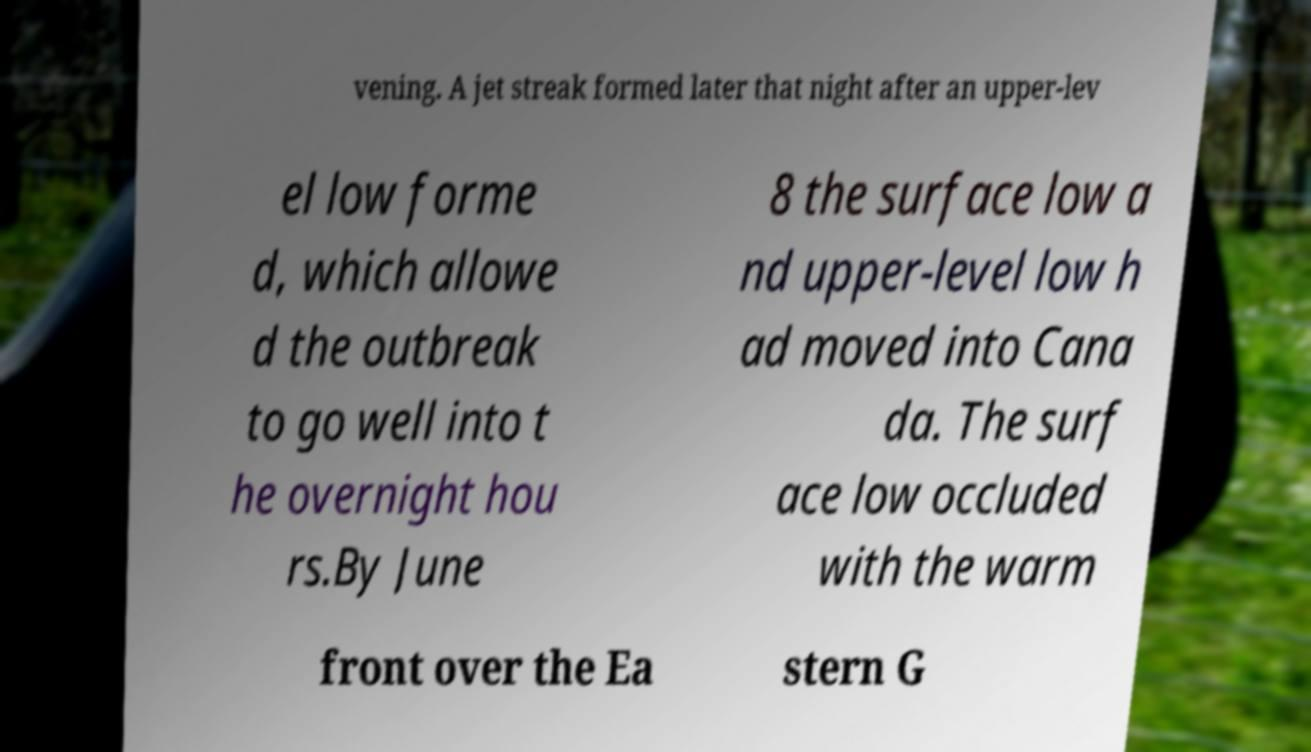Could you assist in decoding the text presented in this image and type it out clearly? vening. A jet streak formed later that night after an upper-lev el low forme d, which allowe d the outbreak to go well into t he overnight hou rs.By June 8 the surface low a nd upper-level low h ad moved into Cana da. The surf ace low occluded with the warm front over the Ea stern G 